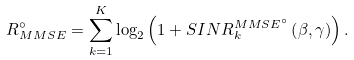<formula> <loc_0><loc_0><loc_500><loc_500>R _ { M M S E } ^ { \circ } = \sum _ { k = 1 } ^ { K } \log _ { 2 } \left ( 1 + S I N R ^ { M M S E ^ { \circ } } _ { k } \left ( \beta , \gamma \right ) \right ) .</formula> 